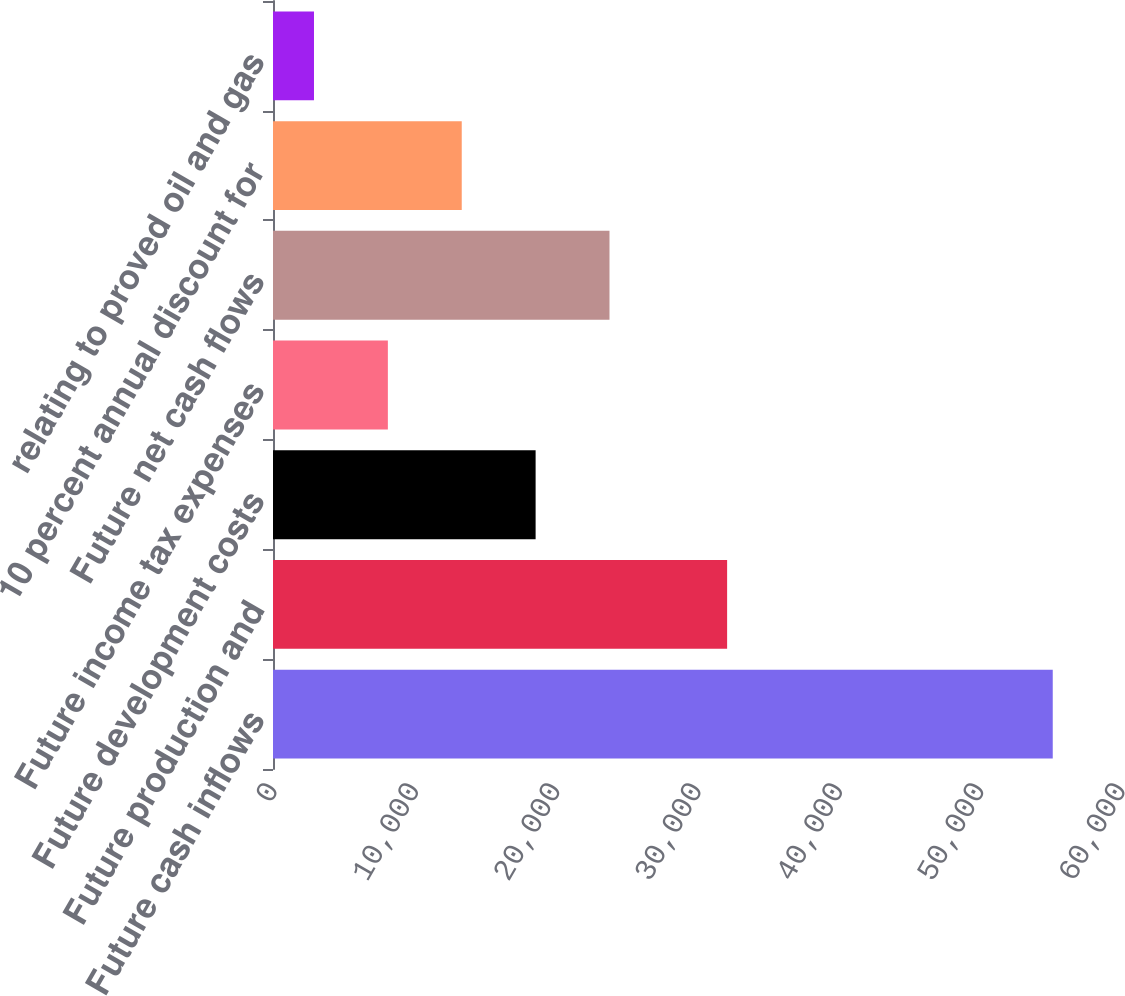Convert chart to OTSL. <chart><loc_0><loc_0><loc_500><loc_500><bar_chart><fcel>Future cash inflows<fcel>Future production and<fcel>Future development costs<fcel>Future income tax expenses<fcel>Future net cash flows<fcel>10 percent annual discount for<fcel>relating to proved oil and gas<nl><fcel>55171<fcel>32131<fcel>18581.3<fcel>8127.1<fcel>23808.4<fcel>13354.2<fcel>2900<nl></chart> 